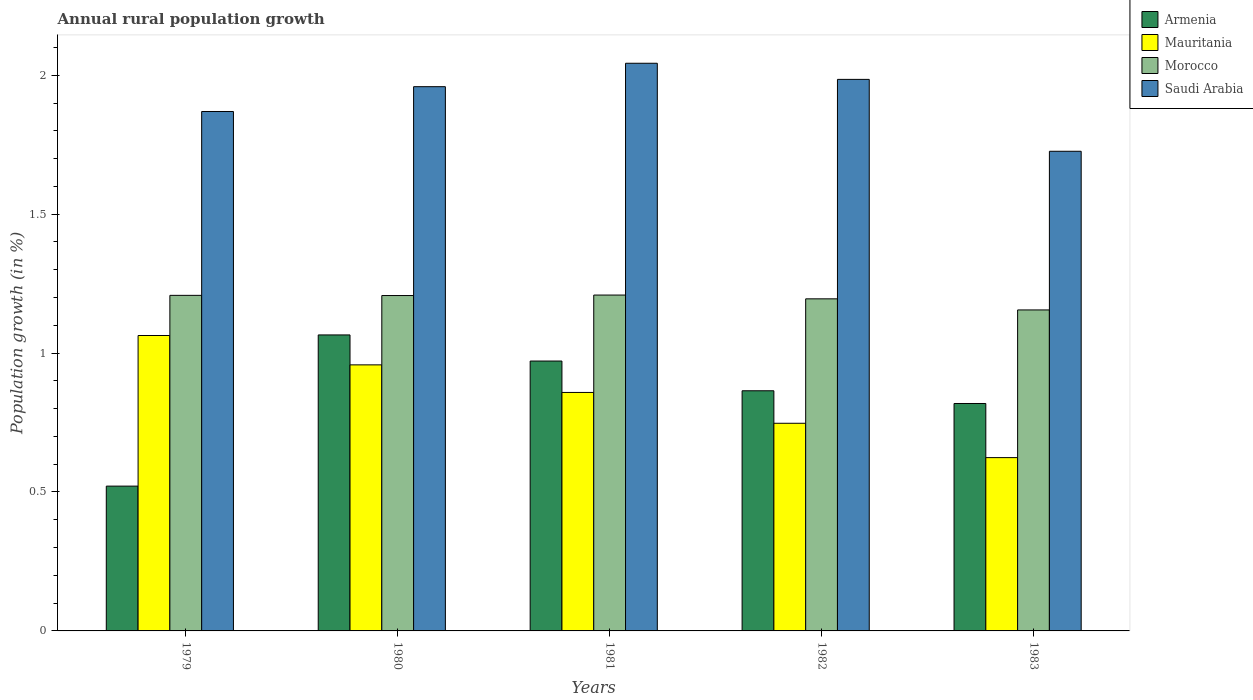How many different coloured bars are there?
Provide a succinct answer. 4. Are the number of bars per tick equal to the number of legend labels?
Offer a terse response. Yes. What is the label of the 1st group of bars from the left?
Provide a succinct answer. 1979. What is the percentage of rural population growth in Armenia in 1983?
Provide a succinct answer. 0.82. Across all years, what is the maximum percentage of rural population growth in Mauritania?
Keep it short and to the point. 1.06. Across all years, what is the minimum percentage of rural population growth in Saudi Arabia?
Keep it short and to the point. 1.73. In which year was the percentage of rural population growth in Mauritania maximum?
Your response must be concise. 1979. In which year was the percentage of rural population growth in Morocco minimum?
Make the answer very short. 1983. What is the total percentage of rural population growth in Mauritania in the graph?
Ensure brevity in your answer.  4.25. What is the difference between the percentage of rural population growth in Armenia in 1980 and that in 1981?
Make the answer very short. 0.09. What is the difference between the percentage of rural population growth in Morocco in 1979 and the percentage of rural population growth in Saudi Arabia in 1980?
Your answer should be very brief. -0.75. What is the average percentage of rural population growth in Mauritania per year?
Keep it short and to the point. 0.85. In the year 1982, what is the difference between the percentage of rural population growth in Saudi Arabia and percentage of rural population growth in Armenia?
Keep it short and to the point. 1.12. In how many years, is the percentage of rural population growth in Saudi Arabia greater than 0.1 %?
Provide a short and direct response. 5. What is the ratio of the percentage of rural population growth in Mauritania in 1980 to that in 1983?
Give a very brief answer. 1.54. Is the percentage of rural population growth in Morocco in 1980 less than that in 1981?
Provide a short and direct response. Yes. Is the difference between the percentage of rural population growth in Saudi Arabia in 1981 and 1983 greater than the difference between the percentage of rural population growth in Armenia in 1981 and 1983?
Offer a terse response. Yes. What is the difference between the highest and the second highest percentage of rural population growth in Armenia?
Offer a terse response. 0.09. What is the difference between the highest and the lowest percentage of rural population growth in Saudi Arabia?
Provide a short and direct response. 0.32. In how many years, is the percentage of rural population growth in Morocco greater than the average percentage of rural population growth in Morocco taken over all years?
Give a very brief answer. 4. Is it the case that in every year, the sum of the percentage of rural population growth in Armenia and percentage of rural population growth in Saudi Arabia is greater than the sum of percentage of rural population growth in Morocco and percentage of rural population growth in Mauritania?
Offer a very short reply. Yes. What does the 2nd bar from the left in 1980 represents?
Offer a very short reply. Mauritania. What does the 4th bar from the right in 1980 represents?
Your response must be concise. Armenia. Is it the case that in every year, the sum of the percentage of rural population growth in Mauritania and percentage of rural population growth in Armenia is greater than the percentage of rural population growth in Saudi Arabia?
Your answer should be very brief. No. What is the difference between two consecutive major ticks on the Y-axis?
Keep it short and to the point. 0.5. Are the values on the major ticks of Y-axis written in scientific E-notation?
Offer a very short reply. No. Does the graph contain grids?
Offer a very short reply. No. How are the legend labels stacked?
Keep it short and to the point. Vertical. What is the title of the graph?
Provide a succinct answer. Annual rural population growth. Does "Channel Islands" appear as one of the legend labels in the graph?
Your response must be concise. No. What is the label or title of the Y-axis?
Offer a terse response. Population growth (in %). What is the Population growth (in %) in Armenia in 1979?
Ensure brevity in your answer.  0.52. What is the Population growth (in %) in Mauritania in 1979?
Make the answer very short. 1.06. What is the Population growth (in %) of Morocco in 1979?
Offer a very short reply. 1.21. What is the Population growth (in %) of Saudi Arabia in 1979?
Offer a very short reply. 1.87. What is the Population growth (in %) in Armenia in 1980?
Provide a succinct answer. 1.07. What is the Population growth (in %) of Mauritania in 1980?
Offer a terse response. 0.96. What is the Population growth (in %) of Morocco in 1980?
Your answer should be very brief. 1.21. What is the Population growth (in %) of Saudi Arabia in 1980?
Your answer should be compact. 1.96. What is the Population growth (in %) in Armenia in 1981?
Offer a terse response. 0.97. What is the Population growth (in %) in Mauritania in 1981?
Ensure brevity in your answer.  0.86. What is the Population growth (in %) in Morocco in 1981?
Provide a short and direct response. 1.21. What is the Population growth (in %) of Saudi Arabia in 1981?
Ensure brevity in your answer.  2.04. What is the Population growth (in %) in Armenia in 1982?
Your response must be concise. 0.86. What is the Population growth (in %) of Mauritania in 1982?
Your answer should be compact. 0.75. What is the Population growth (in %) in Morocco in 1982?
Keep it short and to the point. 1.2. What is the Population growth (in %) in Saudi Arabia in 1982?
Offer a terse response. 1.99. What is the Population growth (in %) in Armenia in 1983?
Offer a very short reply. 0.82. What is the Population growth (in %) in Mauritania in 1983?
Ensure brevity in your answer.  0.62. What is the Population growth (in %) of Morocco in 1983?
Your answer should be very brief. 1.16. What is the Population growth (in %) of Saudi Arabia in 1983?
Keep it short and to the point. 1.73. Across all years, what is the maximum Population growth (in %) in Armenia?
Your response must be concise. 1.07. Across all years, what is the maximum Population growth (in %) in Mauritania?
Give a very brief answer. 1.06. Across all years, what is the maximum Population growth (in %) in Morocco?
Your answer should be compact. 1.21. Across all years, what is the maximum Population growth (in %) in Saudi Arabia?
Ensure brevity in your answer.  2.04. Across all years, what is the minimum Population growth (in %) in Armenia?
Provide a succinct answer. 0.52. Across all years, what is the minimum Population growth (in %) of Mauritania?
Provide a short and direct response. 0.62. Across all years, what is the minimum Population growth (in %) in Morocco?
Provide a short and direct response. 1.16. Across all years, what is the minimum Population growth (in %) of Saudi Arabia?
Offer a very short reply. 1.73. What is the total Population growth (in %) in Armenia in the graph?
Give a very brief answer. 4.24. What is the total Population growth (in %) in Mauritania in the graph?
Your answer should be very brief. 4.25. What is the total Population growth (in %) in Morocco in the graph?
Give a very brief answer. 5.97. What is the total Population growth (in %) of Saudi Arabia in the graph?
Make the answer very short. 9.58. What is the difference between the Population growth (in %) in Armenia in 1979 and that in 1980?
Keep it short and to the point. -0.54. What is the difference between the Population growth (in %) of Mauritania in 1979 and that in 1980?
Provide a succinct answer. 0.11. What is the difference between the Population growth (in %) in Morocco in 1979 and that in 1980?
Provide a succinct answer. 0. What is the difference between the Population growth (in %) of Saudi Arabia in 1979 and that in 1980?
Provide a short and direct response. -0.09. What is the difference between the Population growth (in %) of Armenia in 1979 and that in 1981?
Keep it short and to the point. -0.45. What is the difference between the Population growth (in %) in Mauritania in 1979 and that in 1981?
Provide a succinct answer. 0.2. What is the difference between the Population growth (in %) in Morocco in 1979 and that in 1981?
Your answer should be very brief. -0. What is the difference between the Population growth (in %) of Saudi Arabia in 1979 and that in 1981?
Give a very brief answer. -0.17. What is the difference between the Population growth (in %) of Armenia in 1979 and that in 1982?
Provide a short and direct response. -0.34. What is the difference between the Population growth (in %) of Mauritania in 1979 and that in 1982?
Ensure brevity in your answer.  0.32. What is the difference between the Population growth (in %) of Morocco in 1979 and that in 1982?
Your response must be concise. 0.01. What is the difference between the Population growth (in %) in Saudi Arabia in 1979 and that in 1982?
Offer a terse response. -0.12. What is the difference between the Population growth (in %) in Armenia in 1979 and that in 1983?
Your response must be concise. -0.3. What is the difference between the Population growth (in %) in Mauritania in 1979 and that in 1983?
Ensure brevity in your answer.  0.44. What is the difference between the Population growth (in %) of Morocco in 1979 and that in 1983?
Offer a terse response. 0.05. What is the difference between the Population growth (in %) in Saudi Arabia in 1979 and that in 1983?
Keep it short and to the point. 0.14. What is the difference between the Population growth (in %) in Armenia in 1980 and that in 1981?
Give a very brief answer. 0.09. What is the difference between the Population growth (in %) of Mauritania in 1980 and that in 1981?
Your answer should be compact. 0.1. What is the difference between the Population growth (in %) in Morocco in 1980 and that in 1981?
Ensure brevity in your answer.  -0. What is the difference between the Population growth (in %) of Saudi Arabia in 1980 and that in 1981?
Provide a succinct answer. -0.08. What is the difference between the Population growth (in %) in Armenia in 1980 and that in 1982?
Give a very brief answer. 0.2. What is the difference between the Population growth (in %) in Mauritania in 1980 and that in 1982?
Your response must be concise. 0.21. What is the difference between the Population growth (in %) in Morocco in 1980 and that in 1982?
Your response must be concise. 0.01. What is the difference between the Population growth (in %) in Saudi Arabia in 1980 and that in 1982?
Ensure brevity in your answer.  -0.03. What is the difference between the Population growth (in %) in Armenia in 1980 and that in 1983?
Offer a very short reply. 0.25. What is the difference between the Population growth (in %) of Mauritania in 1980 and that in 1983?
Keep it short and to the point. 0.33. What is the difference between the Population growth (in %) of Morocco in 1980 and that in 1983?
Make the answer very short. 0.05. What is the difference between the Population growth (in %) of Saudi Arabia in 1980 and that in 1983?
Your response must be concise. 0.23. What is the difference between the Population growth (in %) in Armenia in 1981 and that in 1982?
Ensure brevity in your answer.  0.11. What is the difference between the Population growth (in %) in Mauritania in 1981 and that in 1982?
Keep it short and to the point. 0.11. What is the difference between the Population growth (in %) in Morocco in 1981 and that in 1982?
Provide a short and direct response. 0.01. What is the difference between the Population growth (in %) in Saudi Arabia in 1981 and that in 1982?
Make the answer very short. 0.06. What is the difference between the Population growth (in %) of Armenia in 1981 and that in 1983?
Your response must be concise. 0.15. What is the difference between the Population growth (in %) in Mauritania in 1981 and that in 1983?
Keep it short and to the point. 0.23. What is the difference between the Population growth (in %) in Morocco in 1981 and that in 1983?
Provide a succinct answer. 0.05. What is the difference between the Population growth (in %) in Saudi Arabia in 1981 and that in 1983?
Your answer should be very brief. 0.32. What is the difference between the Population growth (in %) in Armenia in 1982 and that in 1983?
Your response must be concise. 0.05. What is the difference between the Population growth (in %) in Mauritania in 1982 and that in 1983?
Offer a very short reply. 0.12. What is the difference between the Population growth (in %) in Morocco in 1982 and that in 1983?
Provide a succinct answer. 0.04. What is the difference between the Population growth (in %) in Saudi Arabia in 1982 and that in 1983?
Offer a very short reply. 0.26. What is the difference between the Population growth (in %) in Armenia in 1979 and the Population growth (in %) in Mauritania in 1980?
Ensure brevity in your answer.  -0.44. What is the difference between the Population growth (in %) in Armenia in 1979 and the Population growth (in %) in Morocco in 1980?
Your response must be concise. -0.69. What is the difference between the Population growth (in %) of Armenia in 1979 and the Population growth (in %) of Saudi Arabia in 1980?
Keep it short and to the point. -1.44. What is the difference between the Population growth (in %) in Mauritania in 1979 and the Population growth (in %) in Morocco in 1980?
Ensure brevity in your answer.  -0.14. What is the difference between the Population growth (in %) of Mauritania in 1979 and the Population growth (in %) of Saudi Arabia in 1980?
Keep it short and to the point. -0.9. What is the difference between the Population growth (in %) of Morocco in 1979 and the Population growth (in %) of Saudi Arabia in 1980?
Your answer should be compact. -0.75. What is the difference between the Population growth (in %) of Armenia in 1979 and the Population growth (in %) of Mauritania in 1981?
Provide a short and direct response. -0.34. What is the difference between the Population growth (in %) of Armenia in 1979 and the Population growth (in %) of Morocco in 1981?
Your response must be concise. -0.69. What is the difference between the Population growth (in %) in Armenia in 1979 and the Population growth (in %) in Saudi Arabia in 1981?
Keep it short and to the point. -1.52. What is the difference between the Population growth (in %) in Mauritania in 1979 and the Population growth (in %) in Morocco in 1981?
Offer a very short reply. -0.15. What is the difference between the Population growth (in %) of Mauritania in 1979 and the Population growth (in %) of Saudi Arabia in 1981?
Provide a succinct answer. -0.98. What is the difference between the Population growth (in %) of Morocco in 1979 and the Population growth (in %) of Saudi Arabia in 1981?
Ensure brevity in your answer.  -0.84. What is the difference between the Population growth (in %) in Armenia in 1979 and the Population growth (in %) in Mauritania in 1982?
Offer a terse response. -0.23. What is the difference between the Population growth (in %) of Armenia in 1979 and the Population growth (in %) of Morocco in 1982?
Make the answer very short. -0.67. What is the difference between the Population growth (in %) of Armenia in 1979 and the Population growth (in %) of Saudi Arabia in 1982?
Your answer should be very brief. -1.46. What is the difference between the Population growth (in %) of Mauritania in 1979 and the Population growth (in %) of Morocco in 1982?
Keep it short and to the point. -0.13. What is the difference between the Population growth (in %) of Mauritania in 1979 and the Population growth (in %) of Saudi Arabia in 1982?
Ensure brevity in your answer.  -0.92. What is the difference between the Population growth (in %) in Morocco in 1979 and the Population growth (in %) in Saudi Arabia in 1982?
Your response must be concise. -0.78. What is the difference between the Population growth (in %) of Armenia in 1979 and the Population growth (in %) of Mauritania in 1983?
Make the answer very short. -0.1. What is the difference between the Population growth (in %) of Armenia in 1979 and the Population growth (in %) of Morocco in 1983?
Make the answer very short. -0.63. What is the difference between the Population growth (in %) in Armenia in 1979 and the Population growth (in %) in Saudi Arabia in 1983?
Make the answer very short. -1.21. What is the difference between the Population growth (in %) of Mauritania in 1979 and the Population growth (in %) of Morocco in 1983?
Your answer should be compact. -0.09. What is the difference between the Population growth (in %) of Mauritania in 1979 and the Population growth (in %) of Saudi Arabia in 1983?
Offer a very short reply. -0.66. What is the difference between the Population growth (in %) in Morocco in 1979 and the Population growth (in %) in Saudi Arabia in 1983?
Keep it short and to the point. -0.52. What is the difference between the Population growth (in %) of Armenia in 1980 and the Population growth (in %) of Mauritania in 1981?
Provide a short and direct response. 0.21. What is the difference between the Population growth (in %) in Armenia in 1980 and the Population growth (in %) in Morocco in 1981?
Ensure brevity in your answer.  -0.14. What is the difference between the Population growth (in %) in Armenia in 1980 and the Population growth (in %) in Saudi Arabia in 1981?
Offer a very short reply. -0.98. What is the difference between the Population growth (in %) in Mauritania in 1980 and the Population growth (in %) in Morocco in 1981?
Give a very brief answer. -0.25. What is the difference between the Population growth (in %) of Mauritania in 1980 and the Population growth (in %) of Saudi Arabia in 1981?
Your response must be concise. -1.09. What is the difference between the Population growth (in %) in Morocco in 1980 and the Population growth (in %) in Saudi Arabia in 1981?
Your response must be concise. -0.84. What is the difference between the Population growth (in %) of Armenia in 1980 and the Population growth (in %) of Mauritania in 1982?
Keep it short and to the point. 0.32. What is the difference between the Population growth (in %) in Armenia in 1980 and the Population growth (in %) in Morocco in 1982?
Provide a succinct answer. -0.13. What is the difference between the Population growth (in %) of Armenia in 1980 and the Population growth (in %) of Saudi Arabia in 1982?
Your response must be concise. -0.92. What is the difference between the Population growth (in %) of Mauritania in 1980 and the Population growth (in %) of Morocco in 1982?
Offer a terse response. -0.24. What is the difference between the Population growth (in %) in Mauritania in 1980 and the Population growth (in %) in Saudi Arabia in 1982?
Offer a terse response. -1.03. What is the difference between the Population growth (in %) of Morocco in 1980 and the Population growth (in %) of Saudi Arabia in 1982?
Offer a terse response. -0.78. What is the difference between the Population growth (in %) of Armenia in 1980 and the Population growth (in %) of Mauritania in 1983?
Make the answer very short. 0.44. What is the difference between the Population growth (in %) in Armenia in 1980 and the Population growth (in %) in Morocco in 1983?
Provide a short and direct response. -0.09. What is the difference between the Population growth (in %) of Armenia in 1980 and the Population growth (in %) of Saudi Arabia in 1983?
Provide a succinct answer. -0.66. What is the difference between the Population growth (in %) in Mauritania in 1980 and the Population growth (in %) in Morocco in 1983?
Make the answer very short. -0.2. What is the difference between the Population growth (in %) in Mauritania in 1980 and the Population growth (in %) in Saudi Arabia in 1983?
Make the answer very short. -0.77. What is the difference between the Population growth (in %) of Morocco in 1980 and the Population growth (in %) of Saudi Arabia in 1983?
Your response must be concise. -0.52. What is the difference between the Population growth (in %) of Armenia in 1981 and the Population growth (in %) of Mauritania in 1982?
Offer a very short reply. 0.22. What is the difference between the Population growth (in %) of Armenia in 1981 and the Population growth (in %) of Morocco in 1982?
Give a very brief answer. -0.22. What is the difference between the Population growth (in %) in Armenia in 1981 and the Population growth (in %) in Saudi Arabia in 1982?
Offer a very short reply. -1.01. What is the difference between the Population growth (in %) in Mauritania in 1981 and the Population growth (in %) in Morocco in 1982?
Ensure brevity in your answer.  -0.34. What is the difference between the Population growth (in %) in Mauritania in 1981 and the Population growth (in %) in Saudi Arabia in 1982?
Provide a short and direct response. -1.13. What is the difference between the Population growth (in %) of Morocco in 1981 and the Population growth (in %) of Saudi Arabia in 1982?
Give a very brief answer. -0.78. What is the difference between the Population growth (in %) of Armenia in 1981 and the Population growth (in %) of Mauritania in 1983?
Your response must be concise. 0.35. What is the difference between the Population growth (in %) in Armenia in 1981 and the Population growth (in %) in Morocco in 1983?
Offer a very short reply. -0.18. What is the difference between the Population growth (in %) of Armenia in 1981 and the Population growth (in %) of Saudi Arabia in 1983?
Provide a succinct answer. -0.76. What is the difference between the Population growth (in %) in Mauritania in 1981 and the Population growth (in %) in Morocco in 1983?
Provide a short and direct response. -0.3. What is the difference between the Population growth (in %) of Mauritania in 1981 and the Population growth (in %) of Saudi Arabia in 1983?
Make the answer very short. -0.87. What is the difference between the Population growth (in %) of Morocco in 1981 and the Population growth (in %) of Saudi Arabia in 1983?
Your answer should be compact. -0.52. What is the difference between the Population growth (in %) of Armenia in 1982 and the Population growth (in %) of Mauritania in 1983?
Give a very brief answer. 0.24. What is the difference between the Population growth (in %) of Armenia in 1982 and the Population growth (in %) of Morocco in 1983?
Provide a succinct answer. -0.29. What is the difference between the Population growth (in %) of Armenia in 1982 and the Population growth (in %) of Saudi Arabia in 1983?
Offer a terse response. -0.86. What is the difference between the Population growth (in %) in Mauritania in 1982 and the Population growth (in %) in Morocco in 1983?
Ensure brevity in your answer.  -0.41. What is the difference between the Population growth (in %) in Mauritania in 1982 and the Population growth (in %) in Saudi Arabia in 1983?
Make the answer very short. -0.98. What is the difference between the Population growth (in %) in Morocco in 1982 and the Population growth (in %) in Saudi Arabia in 1983?
Ensure brevity in your answer.  -0.53. What is the average Population growth (in %) in Armenia per year?
Give a very brief answer. 0.85. What is the average Population growth (in %) in Mauritania per year?
Provide a short and direct response. 0.85. What is the average Population growth (in %) in Morocco per year?
Ensure brevity in your answer.  1.19. What is the average Population growth (in %) of Saudi Arabia per year?
Give a very brief answer. 1.92. In the year 1979, what is the difference between the Population growth (in %) of Armenia and Population growth (in %) of Mauritania?
Offer a terse response. -0.54. In the year 1979, what is the difference between the Population growth (in %) in Armenia and Population growth (in %) in Morocco?
Your answer should be compact. -0.69. In the year 1979, what is the difference between the Population growth (in %) in Armenia and Population growth (in %) in Saudi Arabia?
Your answer should be very brief. -1.35. In the year 1979, what is the difference between the Population growth (in %) of Mauritania and Population growth (in %) of Morocco?
Keep it short and to the point. -0.14. In the year 1979, what is the difference between the Population growth (in %) of Mauritania and Population growth (in %) of Saudi Arabia?
Make the answer very short. -0.81. In the year 1979, what is the difference between the Population growth (in %) in Morocco and Population growth (in %) in Saudi Arabia?
Your response must be concise. -0.66. In the year 1980, what is the difference between the Population growth (in %) in Armenia and Population growth (in %) in Mauritania?
Offer a very short reply. 0.11. In the year 1980, what is the difference between the Population growth (in %) of Armenia and Population growth (in %) of Morocco?
Your answer should be compact. -0.14. In the year 1980, what is the difference between the Population growth (in %) of Armenia and Population growth (in %) of Saudi Arabia?
Give a very brief answer. -0.89. In the year 1980, what is the difference between the Population growth (in %) in Mauritania and Population growth (in %) in Morocco?
Offer a very short reply. -0.25. In the year 1980, what is the difference between the Population growth (in %) of Mauritania and Population growth (in %) of Saudi Arabia?
Keep it short and to the point. -1. In the year 1980, what is the difference between the Population growth (in %) of Morocco and Population growth (in %) of Saudi Arabia?
Your answer should be compact. -0.75. In the year 1981, what is the difference between the Population growth (in %) of Armenia and Population growth (in %) of Mauritania?
Ensure brevity in your answer.  0.11. In the year 1981, what is the difference between the Population growth (in %) of Armenia and Population growth (in %) of Morocco?
Keep it short and to the point. -0.24. In the year 1981, what is the difference between the Population growth (in %) in Armenia and Population growth (in %) in Saudi Arabia?
Provide a succinct answer. -1.07. In the year 1981, what is the difference between the Population growth (in %) in Mauritania and Population growth (in %) in Morocco?
Ensure brevity in your answer.  -0.35. In the year 1981, what is the difference between the Population growth (in %) of Mauritania and Population growth (in %) of Saudi Arabia?
Ensure brevity in your answer.  -1.18. In the year 1981, what is the difference between the Population growth (in %) in Morocco and Population growth (in %) in Saudi Arabia?
Provide a succinct answer. -0.83. In the year 1982, what is the difference between the Population growth (in %) of Armenia and Population growth (in %) of Mauritania?
Provide a succinct answer. 0.12. In the year 1982, what is the difference between the Population growth (in %) in Armenia and Population growth (in %) in Morocco?
Your answer should be compact. -0.33. In the year 1982, what is the difference between the Population growth (in %) of Armenia and Population growth (in %) of Saudi Arabia?
Ensure brevity in your answer.  -1.12. In the year 1982, what is the difference between the Population growth (in %) of Mauritania and Population growth (in %) of Morocco?
Offer a terse response. -0.45. In the year 1982, what is the difference between the Population growth (in %) in Mauritania and Population growth (in %) in Saudi Arabia?
Offer a terse response. -1.24. In the year 1982, what is the difference between the Population growth (in %) in Morocco and Population growth (in %) in Saudi Arabia?
Give a very brief answer. -0.79. In the year 1983, what is the difference between the Population growth (in %) in Armenia and Population growth (in %) in Mauritania?
Give a very brief answer. 0.19. In the year 1983, what is the difference between the Population growth (in %) in Armenia and Population growth (in %) in Morocco?
Offer a terse response. -0.34. In the year 1983, what is the difference between the Population growth (in %) of Armenia and Population growth (in %) of Saudi Arabia?
Offer a terse response. -0.91. In the year 1983, what is the difference between the Population growth (in %) in Mauritania and Population growth (in %) in Morocco?
Give a very brief answer. -0.53. In the year 1983, what is the difference between the Population growth (in %) in Mauritania and Population growth (in %) in Saudi Arabia?
Offer a terse response. -1.1. In the year 1983, what is the difference between the Population growth (in %) of Morocco and Population growth (in %) of Saudi Arabia?
Keep it short and to the point. -0.57. What is the ratio of the Population growth (in %) in Armenia in 1979 to that in 1980?
Your response must be concise. 0.49. What is the ratio of the Population growth (in %) in Mauritania in 1979 to that in 1980?
Offer a terse response. 1.11. What is the ratio of the Population growth (in %) in Saudi Arabia in 1979 to that in 1980?
Keep it short and to the point. 0.95. What is the ratio of the Population growth (in %) of Armenia in 1979 to that in 1981?
Keep it short and to the point. 0.54. What is the ratio of the Population growth (in %) of Mauritania in 1979 to that in 1981?
Offer a very short reply. 1.24. What is the ratio of the Population growth (in %) in Morocco in 1979 to that in 1981?
Provide a succinct answer. 1. What is the ratio of the Population growth (in %) of Saudi Arabia in 1979 to that in 1981?
Provide a short and direct response. 0.92. What is the ratio of the Population growth (in %) in Armenia in 1979 to that in 1982?
Provide a short and direct response. 0.6. What is the ratio of the Population growth (in %) in Mauritania in 1979 to that in 1982?
Give a very brief answer. 1.42. What is the ratio of the Population growth (in %) in Morocco in 1979 to that in 1982?
Your response must be concise. 1.01. What is the ratio of the Population growth (in %) in Saudi Arabia in 1979 to that in 1982?
Make the answer very short. 0.94. What is the ratio of the Population growth (in %) of Armenia in 1979 to that in 1983?
Your answer should be compact. 0.64. What is the ratio of the Population growth (in %) of Mauritania in 1979 to that in 1983?
Give a very brief answer. 1.7. What is the ratio of the Population growth (in %) in Morocco in 1979 to that in 1983?
Your answer should be compact. 1.05. What is the ratio of the Population growth (in %) in Saudi Arabia in 1979 to that in 1983?
Your response must be concise. 1.08. What is the ratio of the Population growth (in %) in Armenia in 1980 to that in 1981?
Your answer should be very brief. 1.1. What is the ratio of the Population growth (in %) of Mauritania in 1980 to that in 1981?
Your answer should be compact. 1.12. What is the ratio of the Population growth (in %) in Morocco in 1980 to that in 1981?
Your answer should be compact. 1. What is the ratio of the Population growth (in %) of Saudi Arabia in 1980 to that in 1981?
Keep it short and to the point. 0.96. What is the ratio of the Population growth (in %) of Armenia in 1980 to that in 1982?
Offer a terse response. 1.23. What is the ratio of the Population growth (in %) of Mauritania in 1980 to that in 1982?
Give a very brief answer. 1.28. What is the ratio of the Population growth (in %) in Morocco in 1980 to that in 1982?
Offer a terse response. 1.01. What is the ratio of the Population growth (in %) of Armenia in 1980 to that in 1983?
Provide a short and direct response. 1.3. What is the ratio of the Population growth (in %) in Mauritania in 1980 to that in 1983?
Provide a short and direct response. 1.54. What is the ratio of the Population growth (in %) of Morocco in 1980 to that in 1983?
Your answer should be compact. 1.04. What is the ratio of the Population growth (in %) of Saudi Arabia in 1980 to that in 1983?
Keep it short and to the point. 1.13. What is the ratio of the Population growth (in %) of Armenia in 1981 to that in 1982?
Provide a short and direct response. 1.12. What is the ratio of the Population growth (in %) of Mauritania in 1981 to that in 1982?
Ensure brevity in your answer.  1.15. What is the ratio of the Population growth (in %) of Morocco in 1981 to that in 1982?
Give a very brief answer. 1.01. What is the ratio of the Population growth (in %) in Saudi Arabia in 1981 to that in 1982?
Give a very brief answer. 1.03. What is the ratio of the Population growth (in %) in Armenia in 1981 to that in 1983?
Offer a very short reply. 1.19. What is the ratio of the Population growth (in %) of Mauritania in 1981 to that in 1983?
Offer a very short reply. 1.38. What is the ratio of the Population growth (in %) in Morocco in 1981 to that in 1983?
Give a very brief answer. 1.05. What is the ratio of the Population growth (in %) of Saudi Arabia in 1981 to that in 1983?
Provide a short and direct response. 1.18. What is the ratio of the Population growth (in %) in Armenia in 1982 to that in 1983?
Provide a short and direct response. 1.06. What is the ratio of the Population growth (in %) of Mauritania in 1982 to that in 1983?
Your answer should be compact. 1.2. What is the ratio of the Population growth (in %) in Morocco in 1982 to that in 1983?
Offer a very short reply. 1.03. What is the ratio of the Population growth (in %) of Saudi Arabia in 1982 to that in 1983?
Provide a succinct answer. 1.15. What is the difference between the highest and the second highest Population growth (in %) in Armenia?
Your answer should be compact. 0.09. What is the difference between the highest and the second highest Population growth (in %) of Mauritania?
Your answer should be very brief. 0.11. What is the difference between the highest and the second highest Population growth (in %) of Morocco?
Offer a terse response. 0. What is the difference between the highest and the second highest Population growth (in %) of Saudi Arabia?
Give a very brief answer. 0.06. What is the difference between the highest and the lowest Population growth (in %) in Armenia?
Provide a short and direct response. 0.54. What is the difference between the highest and the lowest Population growth (in %) in Mauritania?
Your answer should be compact. 0.44. What is the difference between the highest and the lowest Population growth (in %) of Morocco?
Your answer should be compact. 0.05. What is the difference between the highest and the lowest Population growth (in %) of Saudi Arabia?
Offer a very short reply. 0.32. 